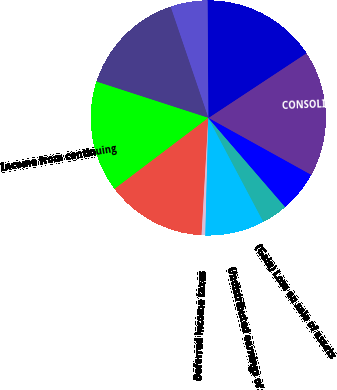Convert chart. <chart><loc_0><loc_0><loc_500><loc_500><pie_chart><fcel>CONSOLIDATED STATEMENTS OF<fcel>Net Income<fcel>Less Net income attributable<fcel>Net income attributable to Air<fcel>Income from continuing<fcel>Depreciation and amortization<fcel>Deferred income taxes<fcel>Undistributed earnings of<fcel>(Gain) Loss on sale of assets<fcel>Share-based compensation<nl><fcel>17.34%<fcel>15.81%<fcel>5.1%<fcel>14.79%<fcel>15.3%<fcel>13.77%<fcel>0.51%<fcel>8.16%<fcel>3.57%<fcel>5.61%<nl></chart> 